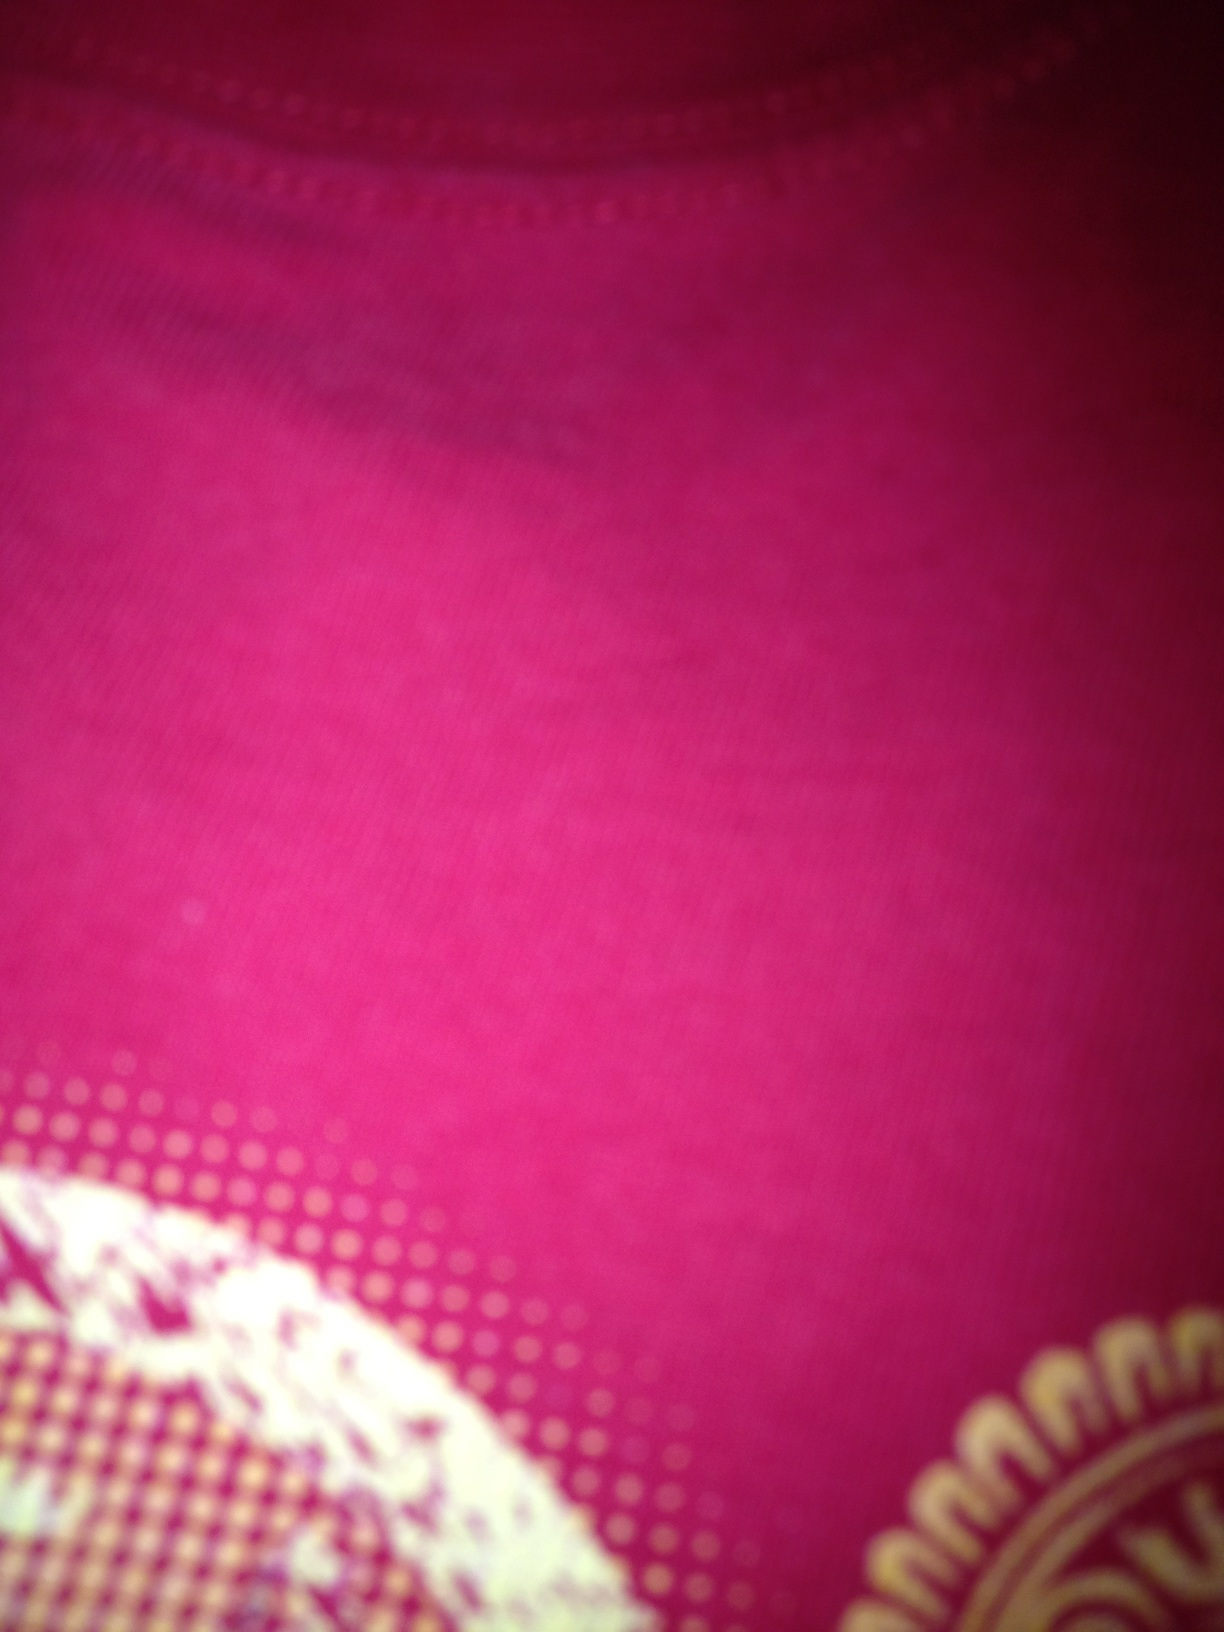What color is this? The item in the image predominantly displays a rich fuchsia shade, which is a vivid purplish red color, often associated with passion and confidence. 